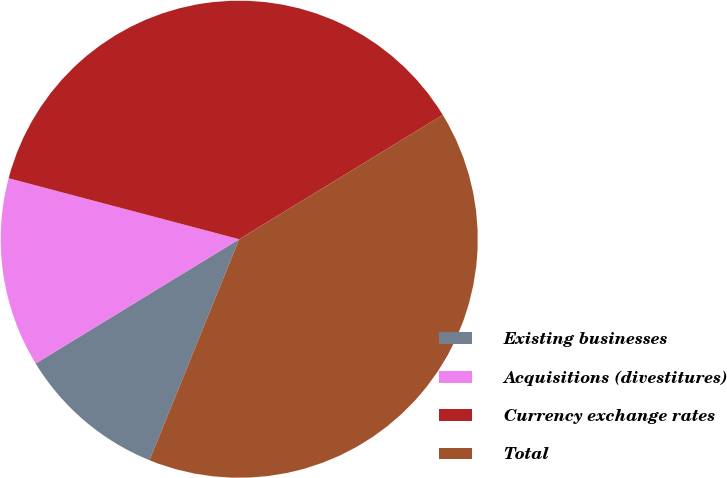Convert chart. <chart><loc_0><loc_0><loc_500><loc_500><pie_chart><fcel>Existing businesses<fcel>Acquisitions (divestitures)<fcel>Currency exchange rates<fcel>Total<nl><fcel>10.14%<fcel>12.84%<fcel>37.16%<fcel>39.86%<nl></chart> 